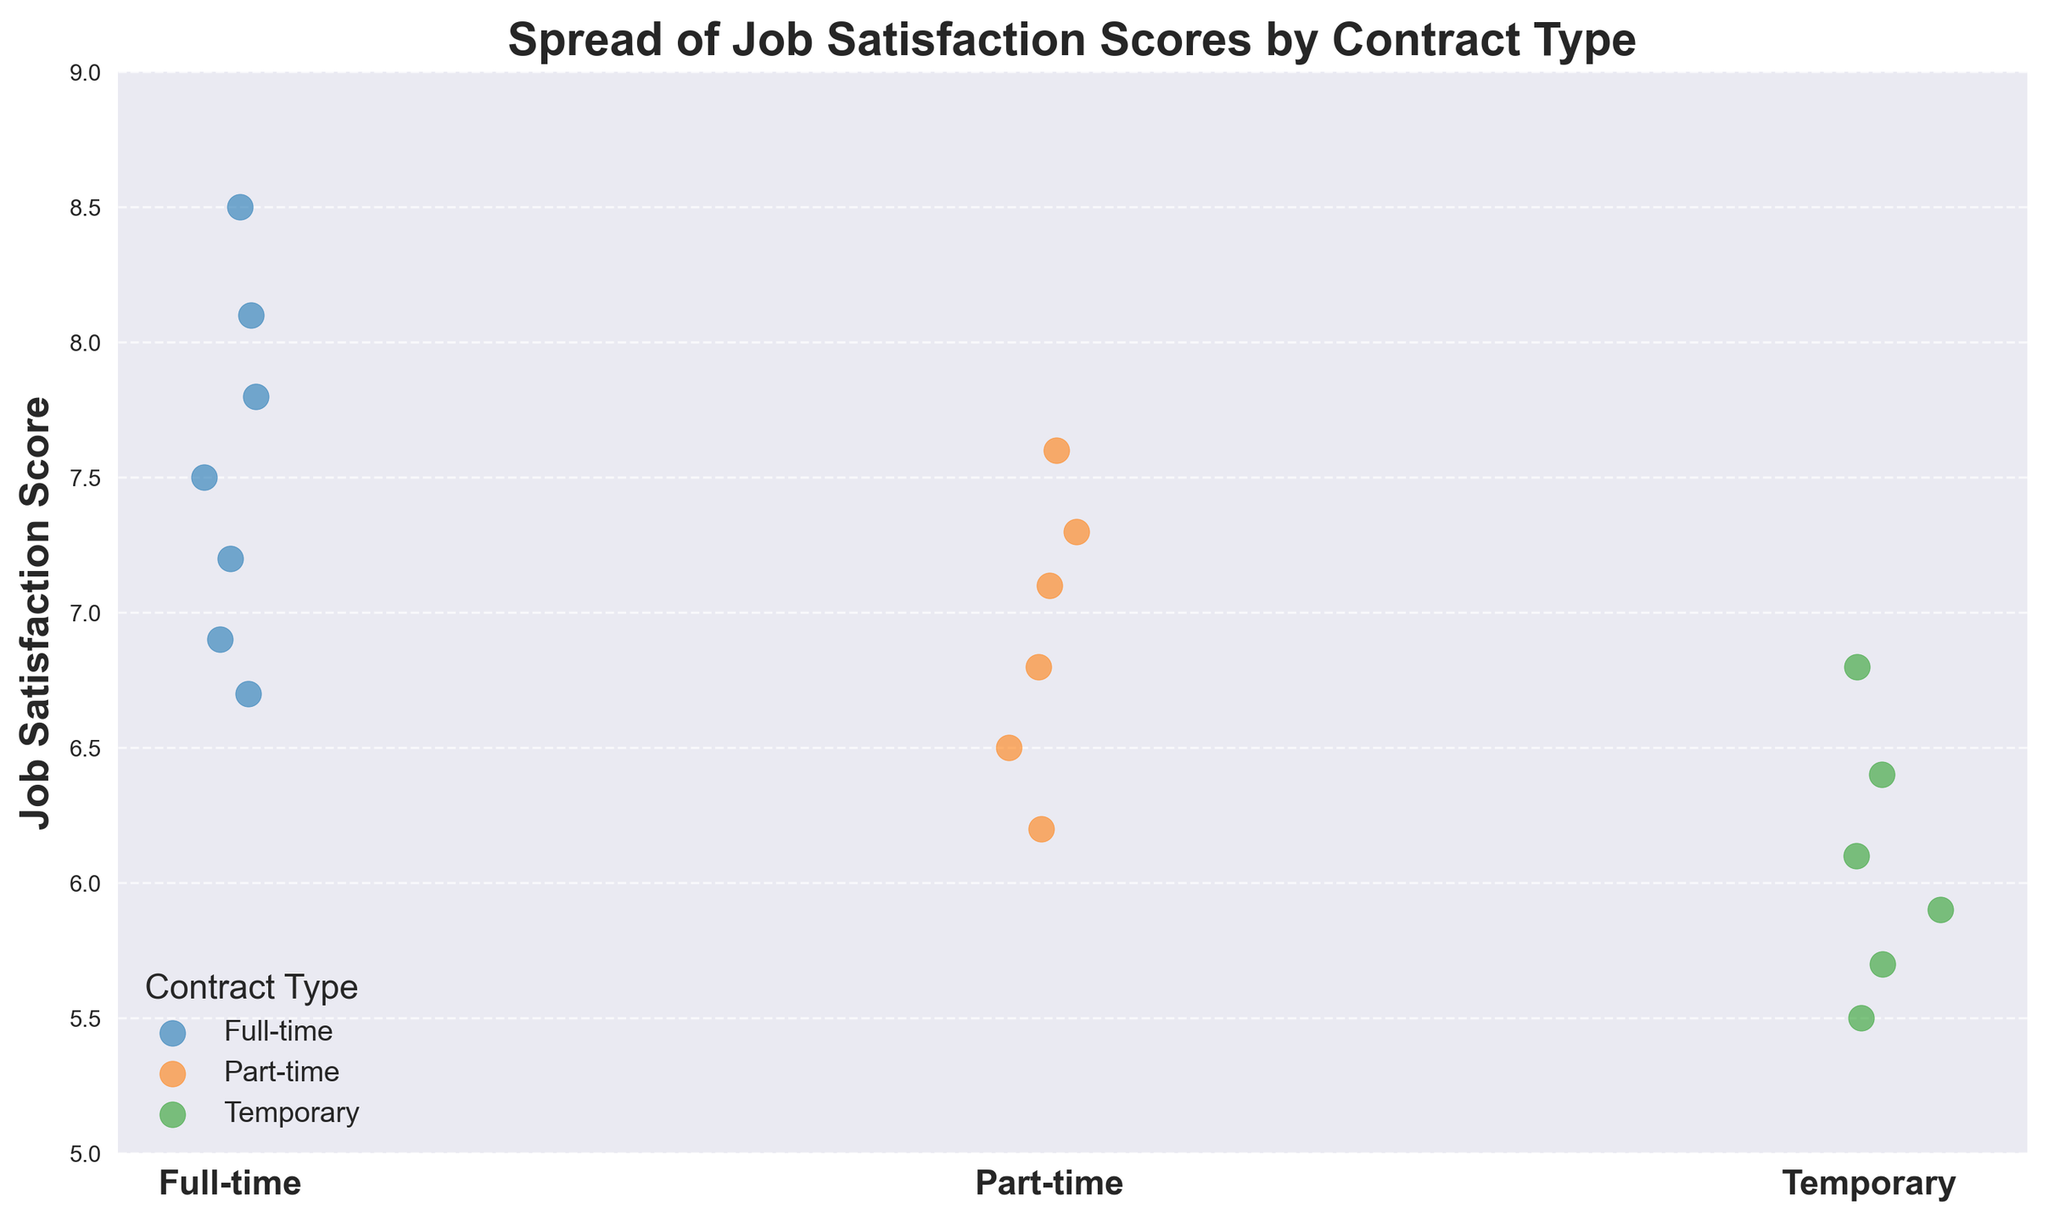What is the title of the plot? The title of the plot is displayed at the top and it reads "Spread of Job Satisfaction Scores by Contract Type."
Answer: Spread of Job Satisfaction Scores by Contract Type Which contract type has the highest job satisfaction scores? By observing the vertical spread of the scores, Full-time workers have the highest job satisfaction scores as they are mostly above 7.0.
Answer: Full-time How many Full-time data points are presented in the plot? Counting the number of scatter points for Full-time on the strip plot, there are 7 Full-time data points.
Answer: 7 What is the range of job satisfaction scores for Temporary workers? The range is calculated by subtracting the minimum score from the maximum score for Temporary workers. The maximum is 6.8 and the minimum is 5.5, so the range is 6.8 - 5.5.
Answer: 1.3 Which contract type shows the lowest job satisfaction score and what is that score? The lowest job satisfaction score is found by checking the minimum scores across all contract types. The lowest score is 5.5, which is seen in the Temporary workers' data.
Answer: Temporary, 5.5 What is the most frequent job satisfaction score for Part-time workers? By visually inspecting the scatter points for Part-time, the most frequent job satisfaction scores seem to cluster around 6.5 and 7.3, with a slight preference towards 7.3.
Answer: 7.3 Compare the job satisfaction scores between Part-time and Temporary workers. Which group has higher scores on average? Comparing both groups, Part-time scores mostly range from 6.2 to 7.6, while Temporary scores range from 5.5 to 6.8. Visually, Part-time workers have higher job satisfaction scores on average.
Answer: Part-time Which contract type has the widest spread in job satisfaction scores? The spread is determined by the visual range between the highest and lowest scores. Full-time workers range from 6.7 to 8.5, which is the widest spread.
Answer: Full-time What is the average job satisfaction score for Full-time workers? To find the average, sum the scores for Full-time workers (7.2, 8.1, 6.9, 7.8, 8.5, 7.5, 6.7) and divide by the number of scores. (7.2 + 8.1 + 6.9 + 7.8 + 8.5 + 7.5 + 6.7) / 7 = 7.53.
Answer: 7.53 